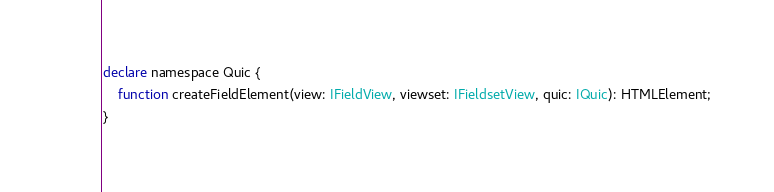Convert code to text. <code><loc_0><loc_0><loc_500><loc_500><_TypeScript_>declare namespace Quic {
    function createFieldElement(view: IFieldView, viewset: IFieldsetView, quic: IQuic): HTMLElement;
}
</code> 